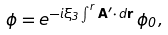Convert formula to latex. <formula><loc_0><loc_0><loc_500><loc_500>\phi = e ^ { - i \xi _ { 3 } \int ^ { r } { \mathbf A } ^ { \prime } \cdot \, d \mathbf r } \, \phi _ { 0 } ,</formula> 